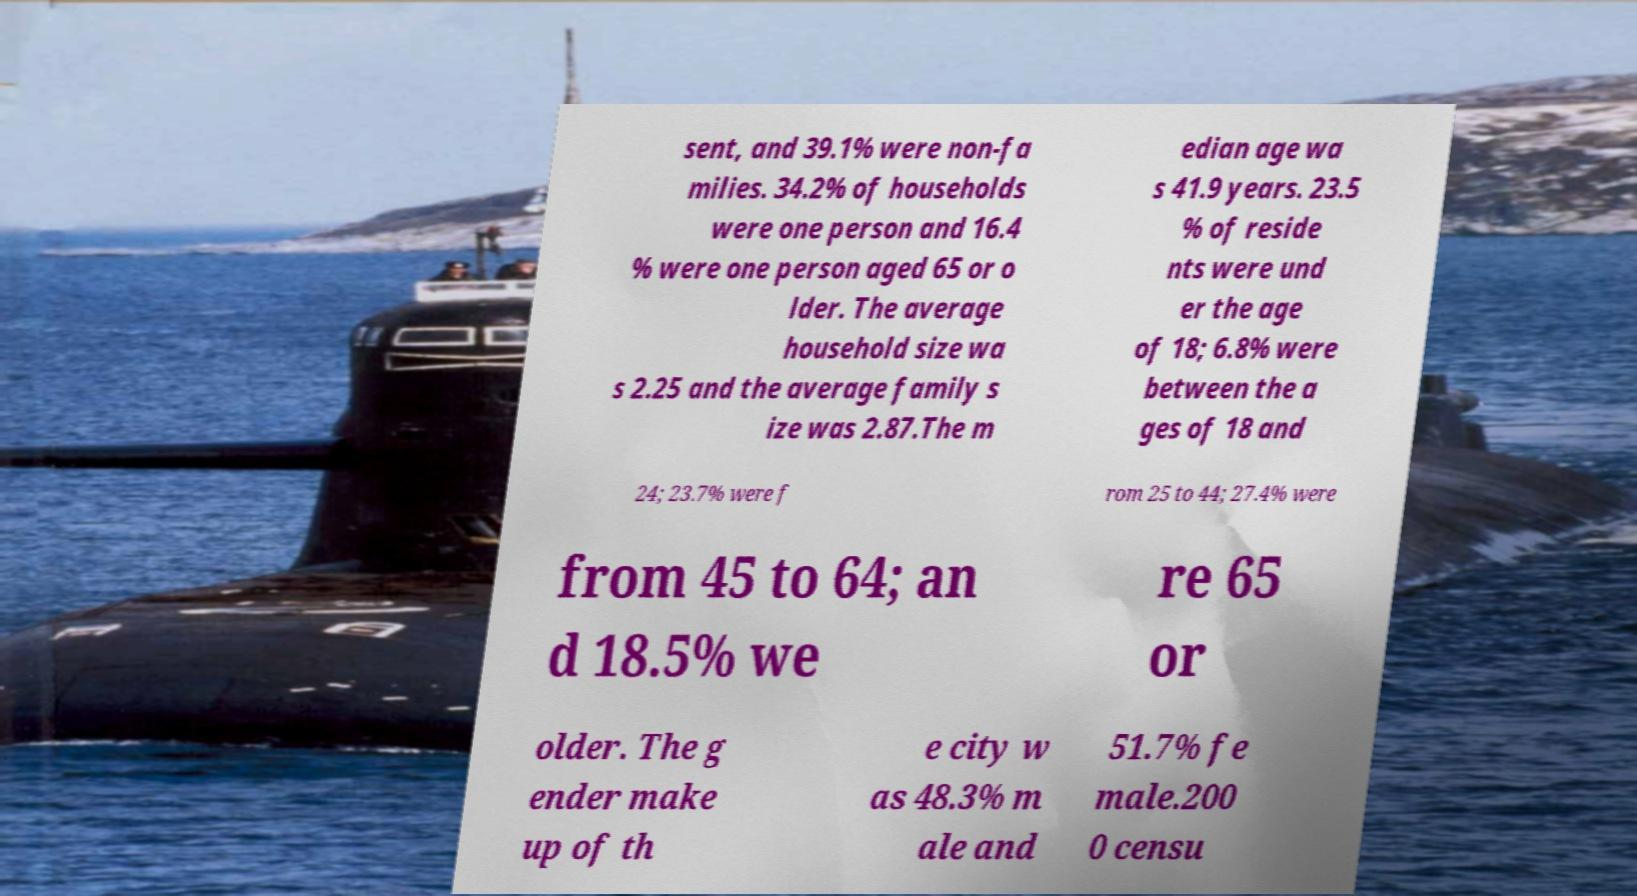I need the written content from this picture converted into text. Can you do that? sent, and 39.1% were non-fa milies. 34.2% of households were one person and 16.4 % were one person aged 65 or o lder. The average household size wa s 2.25 and the average family s ize was 2.87.The m edian age wa s 41.9 years. 23.5 % of reside nts were und er the age of 18; 6.8% were between the a ges of 18 and 24; 23.7% were f rom 25 to 44; 27.4% were from 45 to 64; an d 18.5% we re 65 or older. The g ender make up of th e city w as 48.3% m ale and 51.7% fe male.200 0 censu 